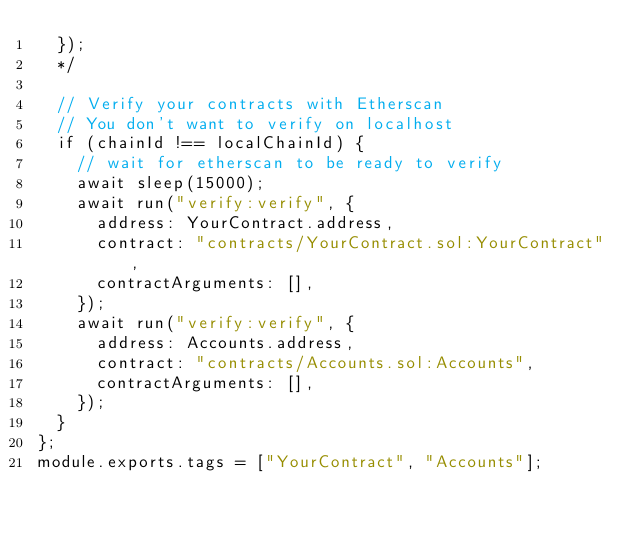<code> <loc_0><loc_0><loc_500><loc_500><_JavaScript_>  });
  */

  // Verify your contracts with Etherscan
  // You don't want to verify on localhost
  if (chainId !== localChainId) {
    // wait for etherscan to be ready to verify
    await sleep(15000);
    await run("verify:verify", {
      address: YourContract.address,
      contract: "contracts/YourContract.sol:YourContract",
      contractArguments: [],
    });
    await run("verify:verify", {
      address: Accounts.address,
      contract: "contracts/Accounts.sol:Accounts",
      contractArguments: [],
    });
  }
};
module.exports.tags = ["YourContract", "Accounts"];
</code> 